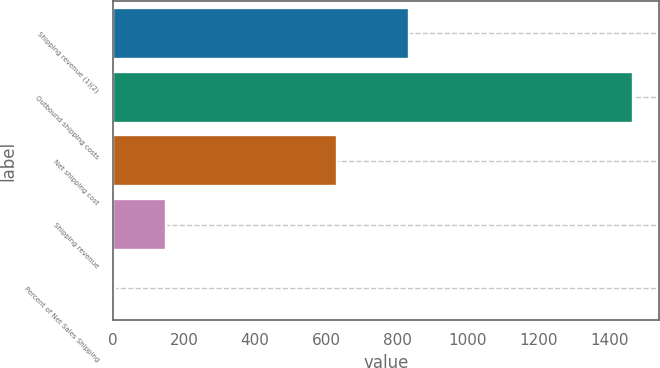Convert chart to OTSL. <chart><loc_0><loc_0><loc_500><loc_500><bar_chart><fcel>Shipping revenue (1)(2)<fcel>Outbound shipping costs<fcel>Net shipping cost<fcel>Shipping revenue<fcel>Percent of Net Sales Shipping<nl><fcel>835<fcel>1465<fcel>630<fcel>150.46<fcel>4.4<nl></chart> 